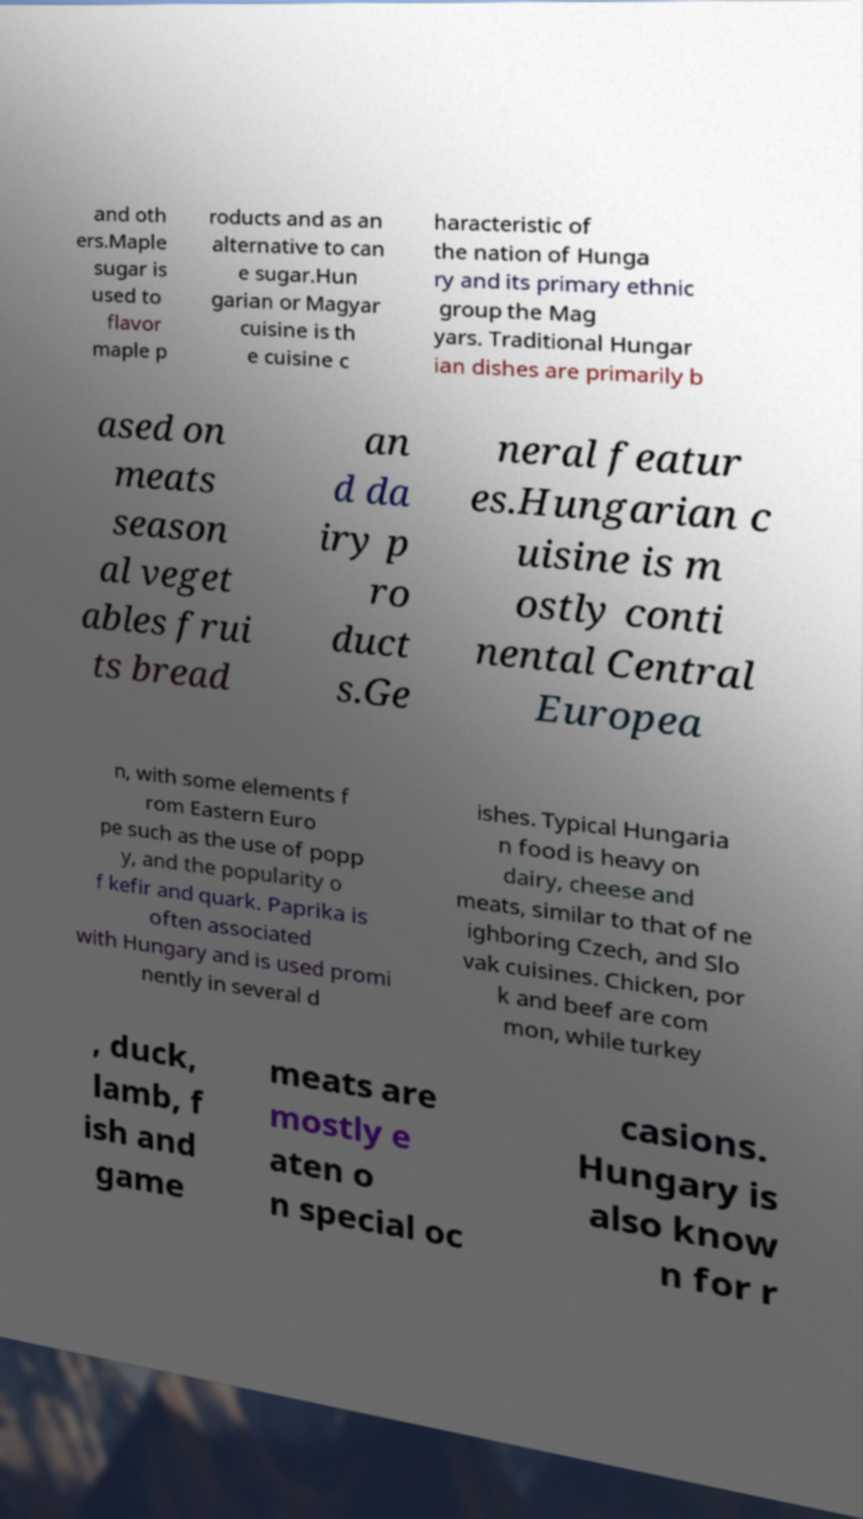Could you assist in decoding the text presented in this image and type it out clearly? and oth ers.Maple sugar is used to flavor maple p roducts and as an alternative to can e sugar.Hun garian or Magyar cuisine is th e cuisine c haracteristic of the nation of Hunga ry and its primary ethnic group the Mag yars. Traditional Hungar ian dishes are primarily b ased on meats season al veget ables frui ts bread an d da iry p ro duct s.Ge neral featur es.Hungarian c uisine is m ostly conti nental Central Europea n, with some elements f rom Eastern Euro pe such as the use of popp y, and the popularity o f kefir and quark. Paprika is often associated with Hungary and is used promi nently in several d ishes. Typical Hungaria n food is heavy on dairy, cheese and meats, similar to that of ne ighboring Czech, and Slo vak cuisines. Chicken, por k and beef are com mon, while turkey , duck, lamb, f ish and game meats are mostly e aten o n special oc casions. Hungary is also know n for r 